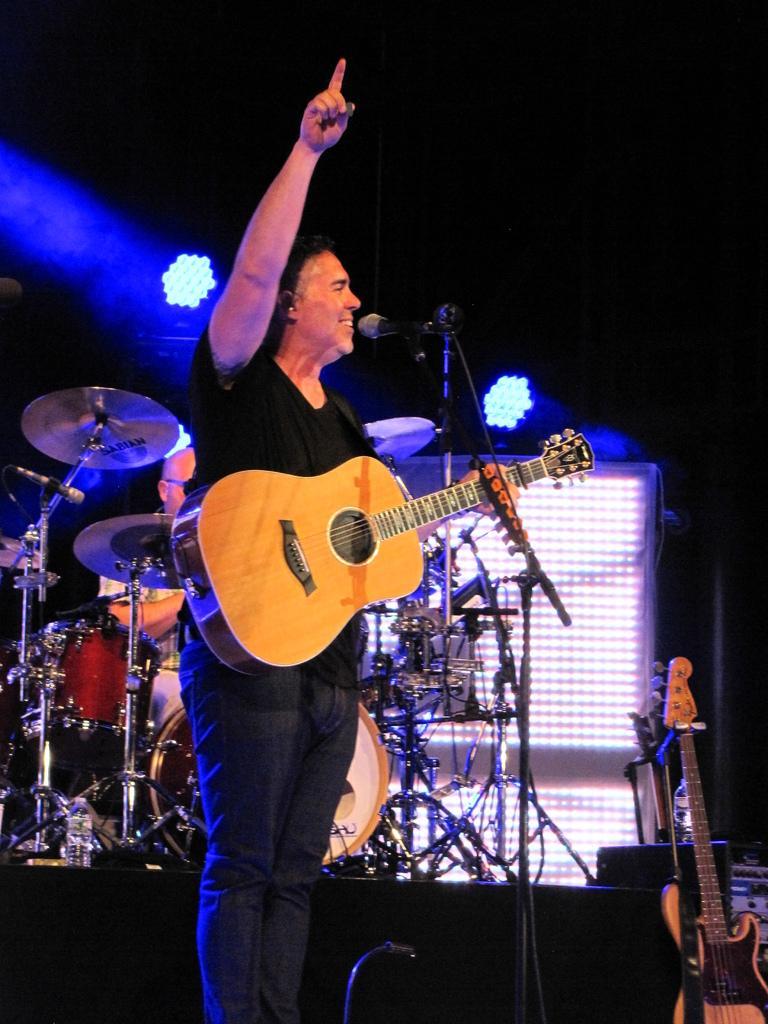Could you give a brief overview of what you see in this image? In this picture there is a man holding a guitar and smiling. In front of him he has a microphone and a stand. 